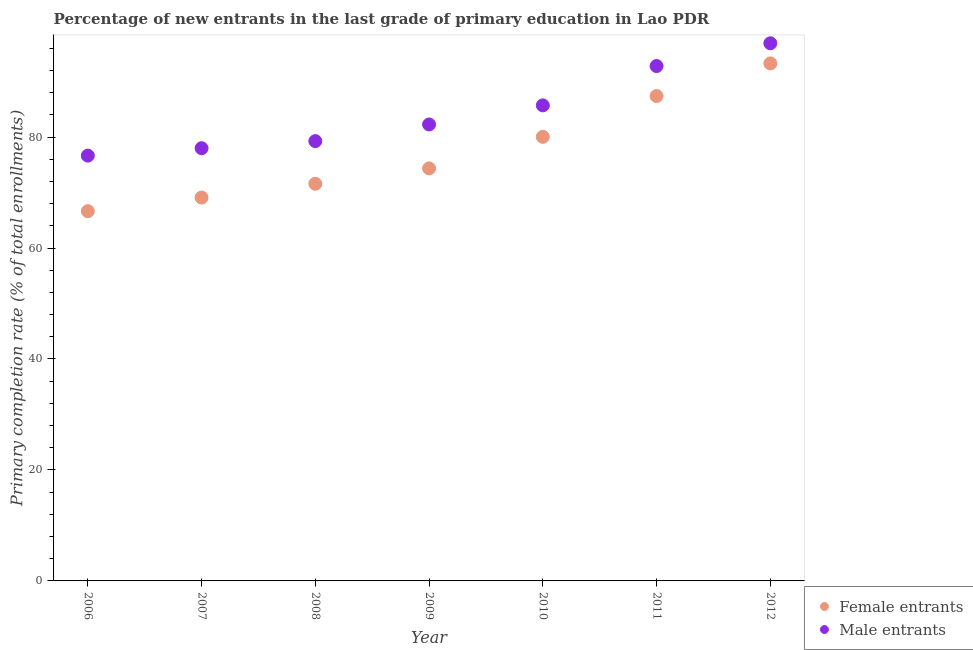How many different coloured dotlines are there?
Your answer should be compact. 2. Is the number of dotlines equal to the number of legend labels?
Offer a very short reply. Yes. What is the primary completion rate of male entrants in 2009?
Ensure brevity in your answer.  82.27. Across all years, what is the maximum primary completion rate of female entrants?
Your answer should be compact. 93.27. Across all years, what is the minimum primary completion rate of male entrants?
Give a very brief answer. 76.66. In which year was the primary completion rate of male entrants maximum?
Your response must be concise. 2012. In which year was the primary completion rate of female entrants minimum?
Your response must be concise. 2006. What is the total primary completion rate of male entrants in the graph?
Your answer should be very brief. 591.59. What is the difference between the primary completion rate of male entrants in 2008 and that in 2011?
Your response must be concise. -13.53. What is the difference between the primary completion rate of male entrants in 2011 and the primary completion rate of female entrants in 2008?
Keep it short and to the point. 21.22. What is the average primary completion rate of female entrants per year?
Your response must be concise. 77.48. In the year 2006, what is the difference between the primary completion rate of male entrants and primary completion rate of female entrants?
Provide a short and direct response. 10.02. What is the ratio of the primary completion rate of female entrants in 2006 to that in 2011?
Provide a short and direct response. 0.76. Is the difference between the primary completion rate of male entrants in 2009 and 2012 greater than the difference between the primary completion rate of female entrants in 2009 and 2012?
Keep it short and to the point. Yes. What is the difference between the highest and the second highest primary completion rate of female entrants?
Make the answer very short. 5.88. What is the difference between the highest and the lowest primary completion rate of female entrants?
Your response must be concise. 26.63. In how many years, is the primary completion rate of male entrants greater than the average primary completion rate of male entrants taken over all years?
Ensure brevity in your answer.  3. Is the primary completion rate of female entrants strictly greater than the primary completion rate of male entrants over the years?
Offer a very short reply. No. How many dotlines are there?
Offer a very short reply. 2. What is the difference between two consecutive major ticks on the Y-axis?
Offer a terse response. 20. Does the graph contain any zero values?
Provide a short and direct response. No. Where does the legend appear in the graph?
Make the answer very short. Bottom right. How many legend labels are there?
Provide a short and direct response. 2. What is the title of the graph?
Your answer should be compact. Percentage of new entrants in the last grade of primary education in Lao PDR. Does "Passenger Transport Items" appear as one of the legend labels in the graph?
Your response must be concise. No. What is the label or title of the Y-axis?
Offer a very short reply. Primary completion rate (% of total enrollments). What is the Primary completion rate (% of total enrollments) of Female entrants in 2006?
Ensure brevity in your answer.  66.64. What is the Primary completion rate (% of total enrollments) of Male entrants in 2006?
Keep it short and to the point. 76.66. What is the Primary completion rate (% of total enrollments) in Female entrants in 2007?
Make the answer very short. 69.09. What is the Primary completion rate (% of total enrollments) of Male entrants in 2007?
Provide a short and direct response. 77.99. What is the Primary completion rate (% of total enrollments) of Female entrants in 2008?
Make the answer very short. 71.58. What is the Primary completion rate (% of total enrollments) in Male entrants in 2008?
Give a very brief answer. 79.26. What is the Primary completion rate (% of total enrollments) of Female entrants in 2009?
Your answer should be compact. 74.35. What is the Primary completion rate (% of total enrollments) of Male entrants in 2009?
Your response must be concise. 82.27. What is the Primary completion rate (% of total enrollments) of Female entrants in 2010?
Ensure brevity in your answer.  80.04. What is the Primary completion rate (% of total enrollments) of Male entrants in 2010?
Your answer should be very brief. 85.71. What is the Primary completion rate (% of total enrollments) in Female entrants in 2011?
Provide a short and direct response. 87.4. What is the Primary completion rate (% of total enrollments) of Male entrants in 2011?
Offer a terse response. 92.8. What is the Primary completion rate (% of total enrollments) in Female entrants in 2012?
Ensure brevity in your answer.  93.27. What is the Primary completion rate (% of total enrollments) of Male entrants in 2012?
Give a very brief answer. 96.9. Across all years, what is the maximum Primary completion rate (% of total enrollments) in Female entrants?
Make the answer very short. 93.27. Across all years, what is the maximum Primary completion rate (% of total enrollments) of Male entrants?
Provide a short and direct response. 96.9. Across all years, what is the minimum Primary completion rate (% of total enrollments) of Female entrants?
Your response must be concise. 66.64. Across all years, what is the minimum Primary completion rate (% of total enrollments) of Male entrants?
Your response must be concise. 76.66. What is the total Primary completion rate (% of total enrollments) in Female entrants in the graph?
Give a very brief answer. 542.38. What is the total Primary completion rate (% of total enrollments) of Male entrants in the graph?
Your response must be concise. 591.59. What is the difference between the Primary completion rate (% of total enrollments) in Female entrants in 2006 and that in 2007?
Your answer should be very brief. -2.45. What is the difference between the Primary completion rate (% of total enrollments) in Male entrants in 2006 and that in 2007?
Ensure brevity in your answer.  -1.34. What is the difference between the Primary completion rate (% of total enrollments) in Female entrants in 2006 and that in 2008?
Your response must be concise. -4.94. What is the difference between the Primary completion rate (% of total enrollments) in Male entrants in 2006 and that in 2008?
Provide a short and direct response. -2.61. What is the difference between the Primary completion rate (% of total enrollments) in Female entrants in 2006 and that in 2009?
Offer a terse response. -7.72. What is the difference between the Primary completion rate (% of total enrollments) in Male entrants in 2006 and that in 2009?
Your answer should be compact. -5.61. What is the difference between the Primary completion rate (% of total enrollments) in Female entrants in 2006 and that in 2010?
Provide a succinct answer. -13.41. What is the difference between the Primary completion rate (% of total enrollments) in Male entrants in 2006 and that in 2010?
Your answer should be very brief. -9.05. What is the difference between the Primary completion rate (% of total enrollments) in Female entrants in 2006 and that in 2011?
Provide a short and direct response. -20.76. What is the difference between the Primary completion rate (% of total enrollments) of Male entrants in 2006 and that in 2011?
Provide a succinct answer. -16.14. What is the difference between the Primary completion rate (% of total enrollments) of Female entrants in 2006 and that in 2012?
Offer a very short reply. -26.64. What is the difference between the Primary completion rate (% of total enrollments) in Male entrants in 2006 and that in 2012?
Offer a very short reply. -20.25. What is the difference between the Primary completion rate (% of total enrollments) of Female entrants in 2007 and that in 2008?
Provide a succinct answer. -2.49. What is the difference between the Primary completion rate (% of total enrollments) of Male entrants in 2007 and that in 2008?
Your response must be concise. -1.27. What is the difference between the Primary completion rate (% of total enrollments) in Female entrants in 2007 and that in 2009?
Make the answer very short. -5.26. What is the difference between the Primary completion rate (% of total enrollments) of Male entrants in 2007 and that in 2009?
Provide a short and direct response. -4.28. What is the difference between the Primary completion rate (% of total enrollments) in Female entrants in 2007 and that in 2010?
Keep it short and to the point. -10.95. What is the difference between the Primary completion rate (% of total enrollments) in Male entrants in 2007 and that in 2010?
Provide a succinct answer. -7.72. What is the difference between the Primary completion rate (% of total enrollments) of Female entrants in 2007 and that in 2011?
Make the answer very short. -18.3. What is the difference between the Primary completion rate (% of total enrollments) of Male entrants in 2007 and that in 2011?
Keep it short and to the point. -14.81. What is the difference between the Primary completion rate (% of total enrollments) of Female entrants in 2007 and that in 2012?
Ensure brevity in your answer.  -24.18. What is the difference between the Primary completion rate (% of total enrollments) in Male entrants in 2007 and that in 2012?
Provide a short and direct response. -18.91. What is the difference between the Primary completion rate (% of total enrollments) of Female entrants in 2008 and that in 2009?
Your response must be concise. -2.77. What is the difference between the Primary completion rate (% of total enrollments) in Male entrants in 2008 and that in 2009?
Provide a short and direct response. -3. What is the difference between the Primary completion rate (% of total enrollments) of Female entrants in 2008 and that in 2010?
Make the answer very short. -8.46. What is the difference between the Primary completion rate (% of total enrollments) of Male entrants in 2008 and that in 2010?
Give a very brief answer. -6.44. What is the difference between the Primary completion rate (% of total enrollments) in Female entrants in 2008 and that in 2011?
Offer a very short reply. -15.81. What is the difference between the Primary completion rate (% of total enrollments) in Male entrants in 2008 and that in 2011?
Your answer should be very brief. -13.53. What is the difference between the Primary completion rate (% of total enrollments) of Female entrants in 2008 and that in 2012?
Keep it short and to the point. -21.69. What is the difference between the Primary completion rate (% of total enrollments) in Male entrants in 2008 and that in 2012?
Offer a terse response. -17.64. What is the difference between the Primary completion rate (% of total enrollments) in Female entrants in 2009 and that in 2010?
Ensure brevity in your answer.  -5.69. What is the difference between the Primary completion rate (% of total enrollments) in Male entrants in 2009 and that in 2010?
Provide a short and direct response. -3.44. What is the difference between the Primary completion rate (% of total enrollments) of Female entrants in 2009 and that in 2011?
Offer a terse response. -13.04. What is the difference between the Primary completion rate (% of total enrollments) of Male entrants in 2009 and that in 2011?
Your answer should be compact. -10.53. What is the difference between the Primary completion rate (% of total enrollments) in Female entrants in 2009 and that in 2012?
Make the answer very short. -18.92. What is the difference between the Primary completion rate (% of total enrollments) of Male entrants in 2009 and that in 2012?
Offer a very short reply. -14.63. What is the difference between the Primary completion rate (% of total enrollments) of Female entrants in 2010 and that in 2011?
Provide a succinct answer. -7.35. What is the difference between the Primary completion rate (% of total enrollments) in Male entrants in 2010 and that in 2011?
Give a very brief answer. -7.09. What is the difference between the Primary completion rate (% of total enrollments) in Female entrants in 2010 and that in 2012?
Make the answer very short. -13.23. What is the difference between the Primary completion rate (% of total enrollments) of Male entrants in 2010 and that in 2012?
Offer a very short reply. -11.19. What is the difference between the Primary completion rate (% of total enrollments) in Female entrants in 2011 and that in 2012?
Provide a short and direct response. -5.88. What is the difference between the Primary completion rate (% of total enrollments) in Male entrants in 2011 and that in 2012?
Offer a very short reply. -4.1. What is the difference between the Primary completion rate (% of total enrollments) in Female entrants in 2006 and the Primary completion rate (% of total enrollments) in Male entrants in 2007?
Provide a short and direct response. -11.35. What is the difference between the Primary completion rate (% of total enrollments) in Female entrants in 2006 and the Primary completion rate (% of total enrollments) in Male entrants in 2008?
Ensure brevity in your answer.  -12.63. What is the difference between the Primary completion rate (% of total enrollments) in Female entrants in 2006 and the Primary completion rate (% of total enrollments) in Male entrants in 2009?
Offer a terse response. -15.63. What is the difference between the Primary completion rate (% of total enrollments) in Female entrants in 2006 and the Primary completion rate (% of total enrollments) in Male entrants in 2010?
Provide a succinct answer. -19.07. What is the difference between the Primary completion rate (% of total enrollments) in Female entrants in 2006 and the Primary completion rate (% of total enrollments) in Male entrants in 2011?
Provide a short and direct response. -26.16. What is the difference between the Primary completion rate (% of total enrollments) of Female entrants in 2006 and the Primary completion rate (% of total enrollments) of Male entrants in 2012?
Your response must be concise. -30.26. What is the difference between the Primary completion rate (% of total enrollments) in Female entrants in 2007 and the Primary completion rate (% of total enrollments) in Male entrants in 2008?
Give a very brief answer. -10.17. What is the difference between the Primary completion rate (% of total enrollments) in Female entrants in 2007 and the Primary completion rate (% of total enrollments) in Male entrants in 2009?
Make the answer very short. -13.18. What is the difference between the Primary completion rate (% of total enrollments) in Female entrants in 2007 and the Primary completion rate (% of total enrollments) in Male entrants in 2010?
Ensure brevity in your answer.  -16.61. What is the difference between the Primary completion rate (% of total enrollments) of Female entrants in 2007 and the Primary completion rate (% of total enrollments) of Male entrants in 2011?
Your response must be concise. -23.7. What is the difference between the Primary completion rate (% of total enrollments) in Female entrants in 2007 and the Primary completion rate (% of total enrollments) in Male entrants in 2012?
Your response must be concise. -27.81. What is the difference between the Primary completion rate (% of total enrollments) of Female entrants in 2008 and the Primary completion rate (% of total enrollments) of Male entrants in 2009?
Make the answer very short. -10.69. What is the difference between the Primary completion rate (% of total enrollments) of Female entrants in 2008 and the Primary completion rate (% of total enrollments) of Male entrants in 2010?
Your answer should be compact. -14.13. What is the difference between the Primary completion rate (% of total enrollments) in Female entrants in 2008 and the Primary completion rate (% of total enrollments) in Male entrants in 2011?
Ensure brevity in your answer.  -21.22. What is the difference between the Primary completion rate (% of total enrollments) of Female entrants in 2008 and the Primary completion rate (% of total enrollments) of Male entrants in 2012?
Keep it short and to the point. -25.32. What is the difference between the Primary completion rate (% of total enrollments) of Female entrants in 2009 and the Primary completion rate (% of total enrollments) of Male entrants in 2010?
Keep it short and to the point. -11.35. What is the difference between the Primary completion rate (% of total enrollments) in Female entrants in 2009 and the Primary completion rate (% of total enrollments) in Male entrants in 2011?
Offer a terse response. -18.44. What is the difference between the Primary completion rate (% of total enrollments) of Female entrants in 2009 and the Primary completion rate (% of total enrollments) of Male entrants in 2012?
Make the answer very short. -22.55. What is the difference between the Primary completion rate (% of total enrollments) in Female entrants in 2010 and the Primary completion rate (% of total enrollments) in Male entrants in 2011?
Provide a succinct answer. -12.75. What is the difference between the Primary completion rate (% of total enrollments) in Female entrants in 2010 and the Primary completion rate (% of total enrollments) in Male entrants in 2012?
Provide a short and direct response. -16.86. What is the difference between the Primary completion rate (% of total enrollments) of Female entrants in 2011 and the Primary completion rate (% of total enrollments) of Male entrants in 2012?
Make the answer very short. -9.51. What is the average Primary completion rate (% of total enrollments) in Female entrants per year?
Give a very brief answer. 77.48. What is the average Primary completion rate (% of total enrollments) in Male entrants per year?
Give a very brief answer. 84.51. In the year 2006, what is the difference between the Primary completion rate (% of total enrollments) in Female entrants and Primary completion rate (% of total enrollments) in Male entrants?
Ensure brevity in your answer.  -10.02. In the year 2007, what is the difference between the Primary completion rate (% of total enrollments) in Female entrants and Primary completion rate (% of total enrollments) in Male entrants?
Keep it short and to the point. -8.9. In the year 2008, what is the difference between the Primary completion rate (% of total enrollments) of Female entrants and Primary completion rate (% of total enrollments) of Male entrants?
Offer a very short reply. -7.68. In the year 2009, what is the difference between the Primary completion rate (% of total enrollments) of Female entrants and Primary completion rate (% of total enrollments) of Male entrants?
Keep it short and to the point. -7.92. In the year 2010, what is the difference between the Primary completion rate (% of total enrollments) in Female entrants and Primary completion rate (% of total enrollments) in Male entrants?
Your response must be concise. -5.66. In the year 2011, what is the difference between the Primary completion rate (% of total enrollments) in Female entrants and Primary completion rate (% of total enrollments) in Male entrants?
Offer a very short reply. -5.4. In the year 2012, what is the difference between the Primary completion rate (% of total enrollments) in Female entrants and Primary completion rate (% of total enrollments) in Male entrants?
Give a very brief answer. -3.63. What is the ratio of the Primary completion rate (% of total enrollments) in Female entrants in 2006 to that in 2007?
Offer a terse response. 0.96. What is the ratio of the Primary completion rate (% of total enrollments) in Male entrants in 2006 to that in 2007?
Ensure brevity in your answer.  0.98. What is the ratio of the Primary completion rate (% of total enrollments) of Female entrants in 2006 to that in 2008?
Your answer should be very brief. 0.93. What is the ratio of the Primary completion rate (% of total enrollments) of Male entrants in 2006 to that in 2008?
Offer a very short reply. 0.97. What is the ratio of the Primary completion rate (% of total enrollments) in Female entrants in 2006 to that in 2009?
Offer a very short reply. 0.9. What is the ratio of the Primary completion rate (% of total enrollments) of Male entrants in 2006 to that in 2009?
Make the answer very short. 0.93. What is the ratio of the Primary completion rate (% of total enrollments) of Female entrants in 2006 to that in 2010?
Your response must be concise. 0.83. What is the ratio of the Primary completion rate (% of total enrollments) in Male entrants in 2006 to that in 2010?
Offer a very short reply. 0.89. What is the ratio of the Primary completion rate (% of total enrollments) in Female entrants in 2006 to that in 2011?
Provide a succinct answer. 0.76. What is the ratio of the Primary completion rate (% of total enrollments) of Male entrants in 2006 to that in 2011?
Keep it short and to the point. 0.83. What is the ratio of the Primary completion rate (% of total enrollments) in Female entrants in 2006 to that in 2012?
Keep it short and to the point. 0.71. What is the ratio of the Primary completion rate (% of total enrollments) in Male entrants in 2006 to that in 2012?
Ensure brevity in your answer.  0.79. What is the ratio of the Primary completion rate (% of total enrollments) of Female entrants in 2007 to that in 2008?
Make the answer very short. 0.97. What is the ratio of the Primary completion rate (% of total enrollments) in Male entrants in 2007 to that in 2008?
Your answer should be very brief. 0.98. What is the ratio of the Primary completion rate (% of total enrollments) of Female entrants in 2007 to that in 2009?
Offer a terse response. 0.93. What is the ratio of the Primary completion rate (% of total enrollments) in Male entrants in 2007 to that in 2009?
Your answer should be very brief. 0.95. What is the ratio of the Primary completion rate (% of total enrollments) in Female entrants in 2007 to that in 2010?
Give a very brief answer. 0.86. What is the ratio of the Primary completion rate (% of total enrollments) in Male entrants in 2007 to that in 2010?
Keep it short and to the point. 0.91. What is the ratio of the Primary completion rate (% of total enrollments) in Female entrants in 2007 to that in 2011?
Offer a terse response. 0.79. What is the ratio of the Primary completion rate (% of total enrollments) of Male entrants in 2007 to that in 2011?
Provide a short and direct response. 0.84. What is the ratio of the Primary completion rate (% of total enrollments) in Female entrants in 2007 to that in 2012?
Make the answer very short. 0.74. What is the ratio of the Primary completion rate (% of total enrollments) in Male entrants in 2007 to that in 2012?
Make the answer very short. 0.8. What is the ratio of the Primary completion rate (% of total enrollments) in Female entrants in 2008 to that in 2009?
Provide a short and direct response. 0.96. What is the ratio of the Primary completion rate (% of total enrollments) in Male entrants in 2008 to that in 2009?
Make the answer very short. 0.96. What is the ratio of the Primary completion rate (% of total enrollments) of Female entrants in 2008 to that in 2010?
Make the answer very short. 0.89. What is the ratio of the Primary completion rate (% of total enrollments) of Male entrants in 2008 to that in 2010?
Make the answer very short. 0.92. What is the ratio of the Primary completion rate (% of total enrollments) in Female entrants in 2008 to that in 2011?
Offer a terse response. 0.82. What is the ratio of the Primary completion rate (% of total enrollments) of Male entrants in 2008 to that in 2011?
Provide a short and direct response. 0.85. What is the ratio of the Primary completion rate (% of total enrollments) in Female entrants in 2008 to that in 2012?
Your answer should be compact. 0.77. What is the ratio of the Primary completion rate (% of total enrollments) in Male entrants in 2008 to that in 2012?
Ensure brevity in your answer.  0.82. What is the ratio of the Primary completion rate (% of total enrollments) in Female entrants in 2009 to that in 2010?
Provide a short and direct response. 0.93. What is the ratio of the Primary completion rate (% of total enrollments) of Male entrants in 2009 to that in 2010?
Your answer should be very brief. 0.96. What is the ratio of the Primary completion rate (% of total enrollments) in Female entrants in 2009 to that in 2011?
Ensure brevity in your answer.  0.85. What is the ratio of the Primary completion rate (% of total enrollments) in Male entrants in 2009 to that in 2011?
Your answer should be compact. 0.89. What is the ratio of the Primary completion rate (% of total enrollments) of Female entrants in 2009 to that in 2012?
Your response must be concise. 0.8. What is the ratio of the Primary completion rate (% of total enrollments) of Male entrants in 2009 to that in 2012?
Keep it short and to the point. 0.85. What is the ratio of the Primary completion rate (% of total enrollments) of Female entrants in 2010 to that in 2011?
Offer a terse response. 0.92. What is the ratio of the Primary completion rate (% of total enrollments) in Male entrants in 2010 to that in 2011?
Ensure brevity in your answer.  0.92. What is the ratio of the Primary completion rate (% of total enrollments) in Female entrants in 2010 to that in 2012?
Offer a very short reply. 0.86. What is the ratio of the Primary completion rate (% of total enrollments) in Male entrants in 2010 to that in 2012?
Give a very brief answer. 0.88. What is the ratio of the Primary completion rate (% of total enrollments) of Female entrants in 2011 to that in 2012?
Offer a terse response. 0.94. What is the ratio of the Primary completion rate (% of total enrollments) of Male entrants in 2011 to that in 2012?
Your answer should be very brief. 0.96. What is the difference between the highest and the second highest Primary completion rate (% of total enrollments) of Female entrants?
Give a very brief answer. 5.88. What is the difference between the highest and the second highest Primary completion rate (% of total enrollments) in Male entrants?
Provide a short and direct response. 4.1. What is the difference between the highest and the lowest Primary completion rate (% of total enrollments) of Female entrants?
Ensure brevity in your answer.  26.64. What is the difference between the highest and the lowest Primary completion rate (% of total enrollments) in Male entrants?
Provide a short and direct response. 20.25. 